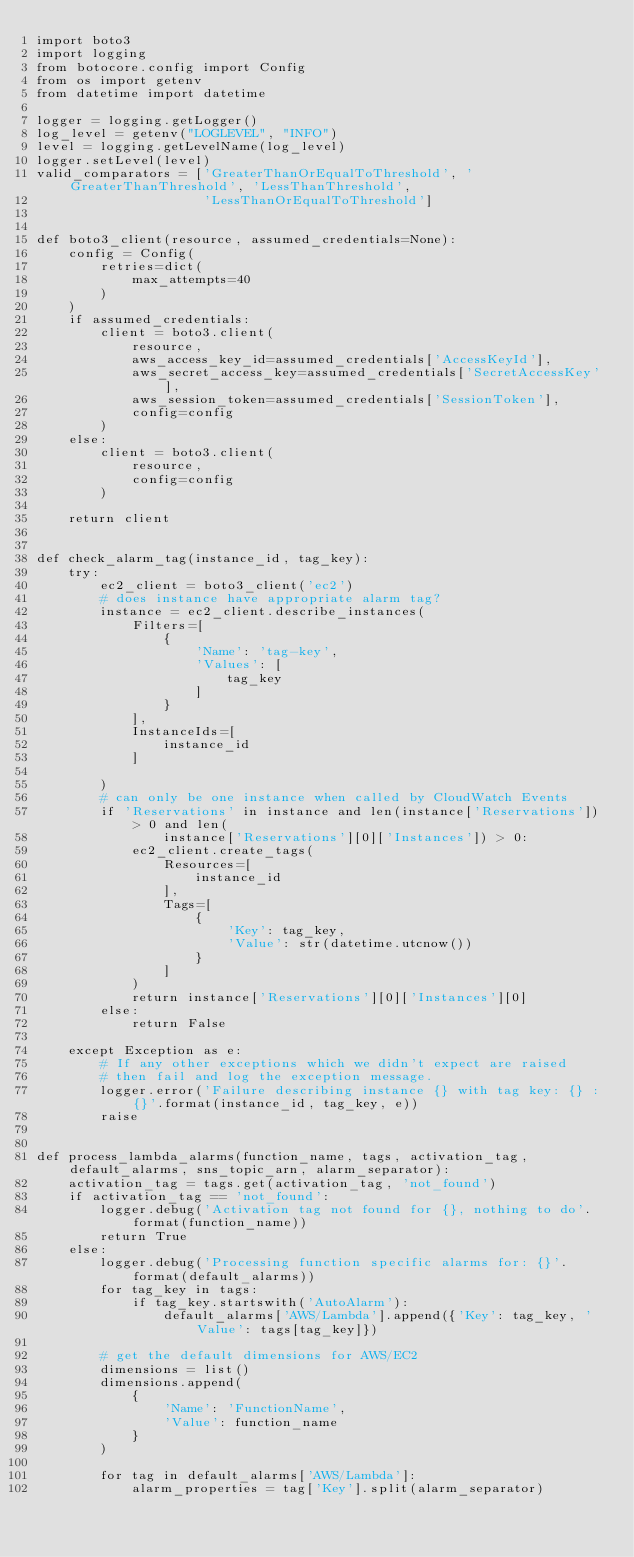<code> <loc_0><loc_0><loc_500><loc_500><_Python_>import boto3
import logging
from botocore.config import Config
from os import getenv
from datetime import datetime

logger = logging.getLogger()
log_level = getenv("LOGLEVEL", "INFO")
level = logging.getLevelName(log_level)
logger.setLevel(level)
valid_comparators = ['GreaterThanOrEqualToThreshold', 'GreaterThanThreshold', 'LessThanThreshold',
                     'LessThanOrEqualToThreshold']


def boto3_client(resource, assumed_credentials=None):
    config = Config(
        retries=dict(
            max_attempts=40
        )
    )
    if assumed_credentials:
        client = boto3.client(
            resource,
            aws_access_key_id=assumed_credentials['AccessKeyId'],
            aws_secret_access_key=assumed_credentials['SecretAccessKey'],
            aws_session_token=assumed_credentials['SessionToken'],
            config=config
        )
    else:
        client = boto3.client(
            resource,
            config=config
        )

    return client


def check_alarm_tag(instance_id, tag_key):
    try:
        ec2_client = boto3_client('ec2')
        # does instance have appropriate alarm tag?
        instance = ec2_client.describe_instances(
            Filters=[
                {
                    'Name': 'tag-key',
                    'Values': [
                        tag_key
                    ]
                }
            ],
            InstanceIds=[
                instance_id
            ]

        )
        # can only be one instance when called by CloudWatch Events
        if 'Reservations' in instance and len(instance['Reservations']) > 0 and len(
                instance['Reservations'][0]['Instances']) > 0:
            ec2_client.create_tags(
                Resources=[
                    instance_id
                ],
                Tags=[
                    {
                        'Key': tag_key,
                        'Value': str(datetime.utcnow())
                    }
                ]
            )
            return instance['Reservations'][0]['Instances'][0]
        else:
            return False

    except Exception as e:
        # If any other exceptions which we didn't expect are raised
        # then fail and log the exception message.
        logger.error('Failure describing instance {} with tag key: {} : {}'.format(instance_id, tag_key, e))
        raise


def process_lambda_alarms(function_name, tags, activation_tag, default_alarms, sns_topic_arn, alarm_separator):
    activation_tag = tags.get(activation_tag, 'not_found')
    if activation_tag == 'not_found':
        logger.debug('Activation tag not found for {}, nothing to do'.format(function_name))
        return True
    else:
        logger.debug('Processing function specific alarms for: {}'.format(default_alarms))
        for tag_key in tags:
            if tag_key.startswith('AutoAlarm'):
                default_alarms['AWS/Lambda'].append({'Key': tag_key, 'Value': tags[tag_key]})

        # get the default dimensions for AWS/EC2
        dimensions = list()
        dimensions.append(
            {
                'Name': 'FunctionName',
                'Value': function_name
            }
        )

        for tag in default_alarms['AWS/Lambda']:
            alarm_properties = tag['Key'].split(alarm_separator)</code> 